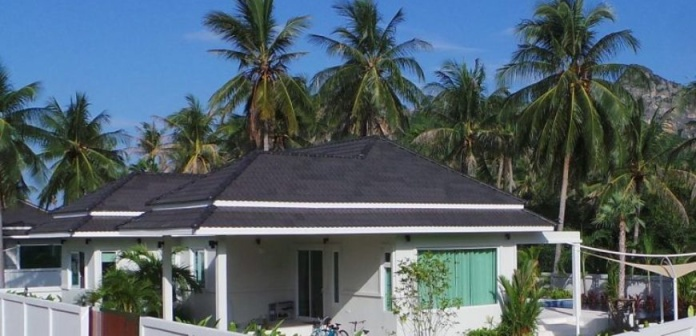What's happening in the scene? The image captures a serene tropical setting. Dominating the scene is a quaint white bungalow, its black roof contrasting sharply with its surroundings. The bungalow's green shutters add a splash of color to the otherwise monochrome structure. A white fence encloses a small garden in front of the bungalow, adding to the homely feel of the scene.

Two bicycles, parked side by side, rest against the fence, suggesting the presence of inhabitants or visitors. The bungalow is nestled amidst lush greenery, with towering palm trees swaying gently in the background. Beyond the trees, majestic mountains loom, their peaks obscured by a veil of mist.

Every element in the image, from the bungalow to the bicycles, the palm trees to the mountains, contributes to a sense of tranquility and escape, painting a picture of a peaceful retreat away from the hustle and bustle of city life. 